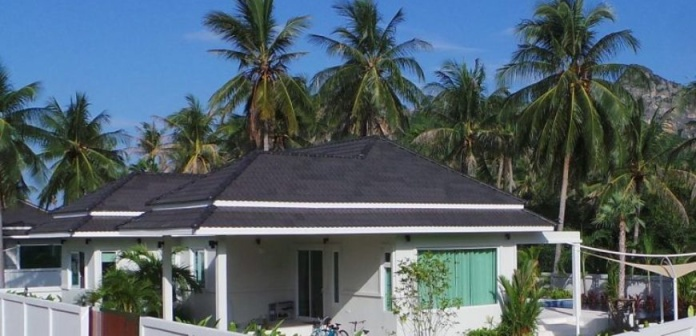What's happening in the scene? The image captures a serene tropical setting. Dominating the scene is a quaint white bungalow, its black roof contrasting sharply with its surroundings. The bungalow's green shutters add a splash of color to the otherwise monochrome structure. A white fence encloses a small garden in front of the bungalow, adding to the homely feel of the scene.

Two bicycles, parked side by side, rest against the fence, suggesting the presence of inhabitants or visitors. The bungalow is nestled amidst lush greenery, with towering palm trees swaying gently in the background. Beyond the trees, majestic mountains loom, their peaks obscured by a veil of mist.

Every element in the image, from the bungalow to the bicycles, the palm trees to the mountains, contributes to a sense of tranquility and escape, painting a picture of a peaceful retreat away from the hustle and bustle of city life. 